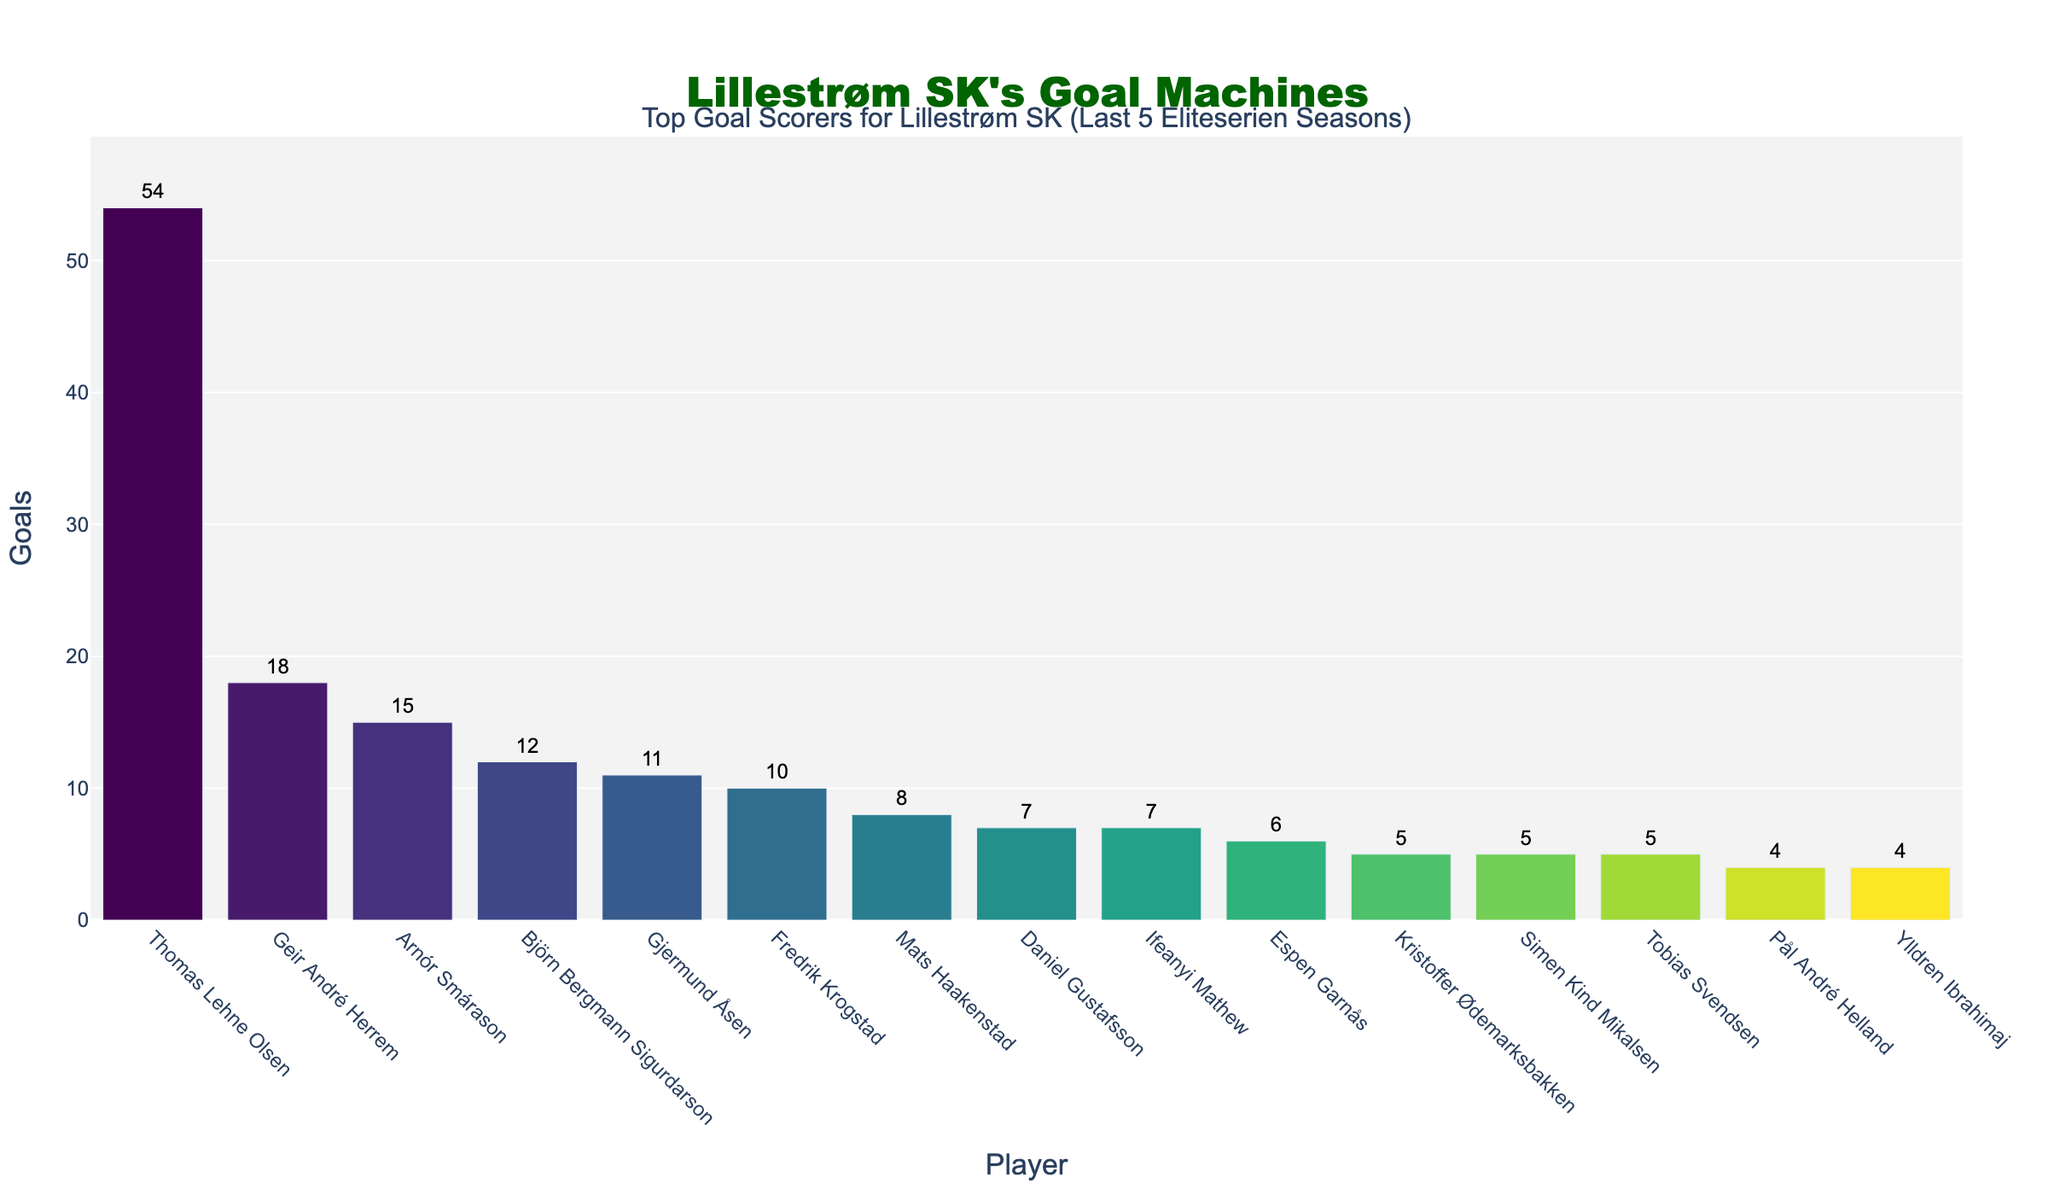Who is the top goal scorer for Lillestrøm SK in the last 5 Eliteserien seasons? The data shows the top goal scorer as "Thomas Lehne Olsen" with the highest bar and 54 goals.
Answer: Thomas Lehne Olsen How many more goals did Thomas Lehne Olsen score compared to Geir André Herrem? Thomas Lehne Olsen scored 54 goals, and Geir André Herrem scored 18 goals. The difference is 54 - 18 = 36 goals.
Answer: 36 What is the total number of goals scored by the top three players? The top three players are Thomas Lehne Olsen (54 goals), Geir André Herrem (18 goals), and Arnór Smárason (15 goals). Total goals = 54 + 18 + 15 = 87 goals.
Answer: 87 Which player scored the least number of goals, and how many? The players who scored the least are Pål André Helland and Ylldren Ibrahimaj, each with 4 goals, indicated by the smallest bars.
Answer: Pål André Helland, Ylldren Ibrahimaj; 4 goals How many players scored more than 10 goals? Observing the bars, Thomas Lehne Olsen, Geir André Herrem, Arnór Smárason, Björn Bergmann Sigurdarson, and Gjermund Åsen scored more than 10 goals. Thus, 5 players.
Answer: 5 What is the average number of goals scored by the top five goal scorers? The top five players are Thomas Lehne Olsen (54), Geir André Herrem (18), Arnór Smárason (15), Björn Bergmann Sigurdarson (12), and Gjermund Åsen (11). Average = (54 + 18 + 15 + 12 + 11) / 5 = 22.
Answer: 22 Compare the goals of Fredrik Krogstad and Mats Haakenstad. Who scored more, and by how many? Fredrik Krogstad scored 10 goals, and Mats Haakenstad scored 8 goals. Krogstad scored 10 - 8 = 2 goals more.
Answer: Fredrik Krogstad; 2 What is the combined goal count of players who scored exactly 5 goals? The players Kristoffer Ødemarksbakken, Simen Kind Mikalsen, and Tobias Svendsen each scored 5 goals. Combined goals = 5 + 5 + 5 = 15.
Answer: 15 What is the total number of goals scored by all players in the last 5 seasons? Sum of all goals: 54 + 18 + 15 + 12 + 11 + 10 + 8 + 7 + 7 + 6 + 5 + 5 + 5 + 4 + 4 = 171 goals.
Answer: 171 